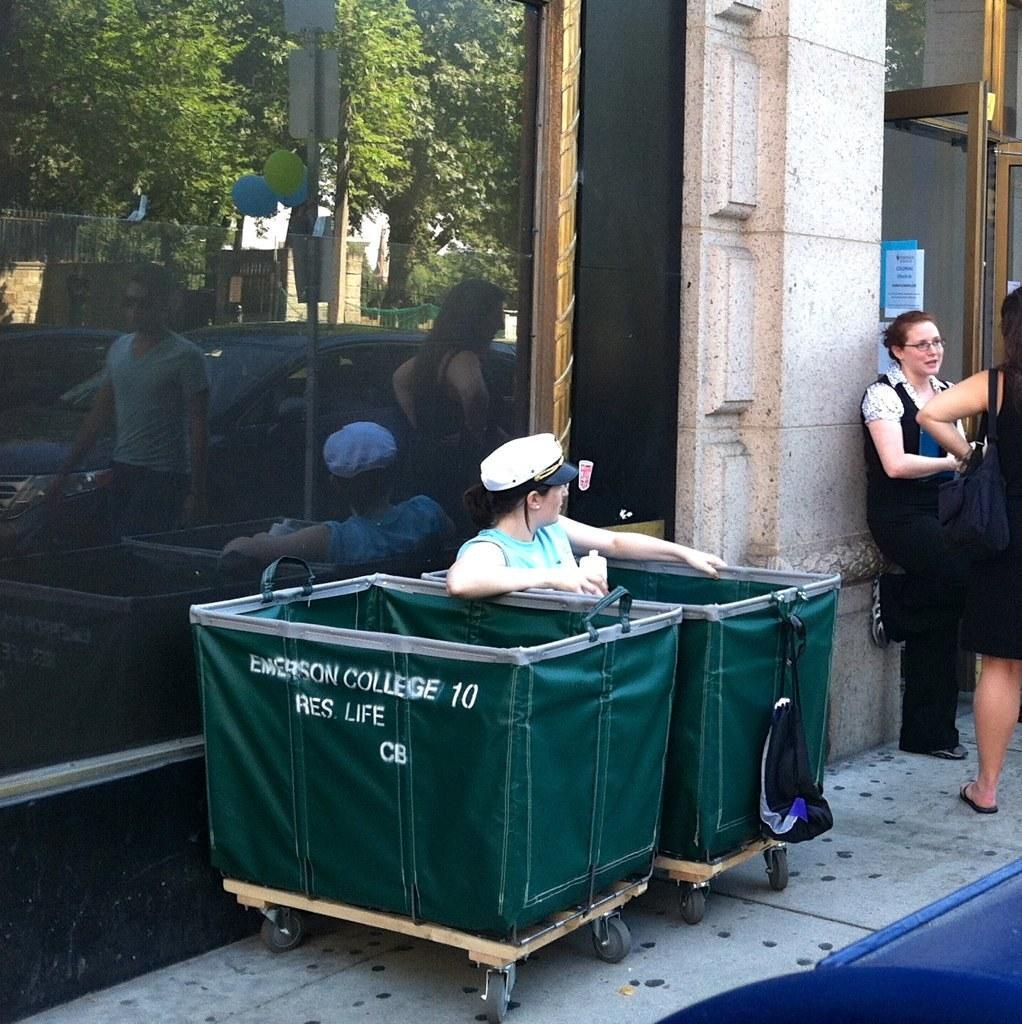Please provide a concise description of this image. In this picture i can see a person is sitting in a box. The person is wearing cap. I can also see two women are standing. In the background i can see a glass wall, trees and other objects. 